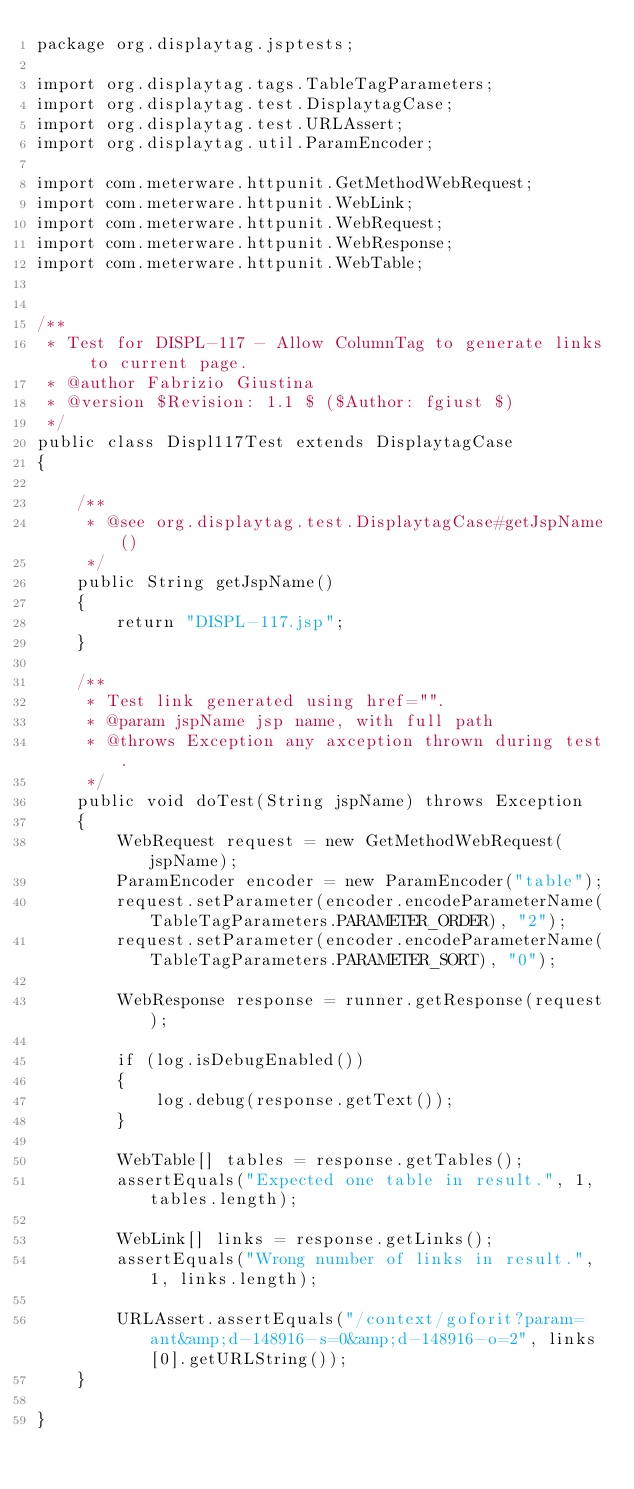Convert code to text. <code><loc_0><loc_0><loc_500><loc_500><_Java_>package org.displaytag.jsptests;

import org.displaytag.tags.TableTagParameters;
import org.displaytag.test.DisplaytagCase;
import org.displaytag.test.URLAssert;
import org.displaytag.util.ParamEncoder;

import com.meterware.httpunit.GetMethodWebRequest;
import com.meterware.httpunit.WebLink;
import com.meterware.httpunit.WebRequest;
import com.meterware.httpunit.WebResponse;
import com.meterware.httpunit.WebTable;


/**
 * Test for DISPL-117 - Allow ColumnTag to generate links to current page.
 * @author Fabrizio Giustina
 * @version $Revision: 1.1 $ ($Author: fgiust $)
 */
public class Displ117Test extends DisplaytagCase
{

    /**
     * @see org.displaytag.test.DisplaytagCase#getJspName()
     */
    public String getJspName()
    {
        return "DISPL-117.jsp";
    }

    /**
     * Test link generated using href="".
     * @param jspName jsp name, with full path
     * @throws Exception any axception thrown during test.
     */
    public void doTest(String jspName) throws Exception
    {
        WebRequest request = new GetMethodWebRequest(jspName);
        ParamEncoder encoder = new ParamEncoder("table");
        request.setParameter(encoder.encodeParameterName(TableTagParameters.PARAMETER_ORDER), "2");
        request.setParameter(encoder.encodeParameterName(TableTagParameters.PARAMETER_SORT), "0");

        WebResponse response = runner.getResponse(request);

        if (log.isDebugEnabled())
        {
            log.debug(response.getText());
        }

        WebTable[] tables = response.getTables();
        assertEquals("Expected one table in result.", 1, tables.length);

        WebLink[] links = response.getLinks();
        assertEquals("Wrong number of links in result.", 1, links.length);

        URLAssert.assertEquals("/context/goforit?param=ant&amp;d-148916-s=0&amp;d-148916-o=2", links[0].getURLString());
    }

}</code> 